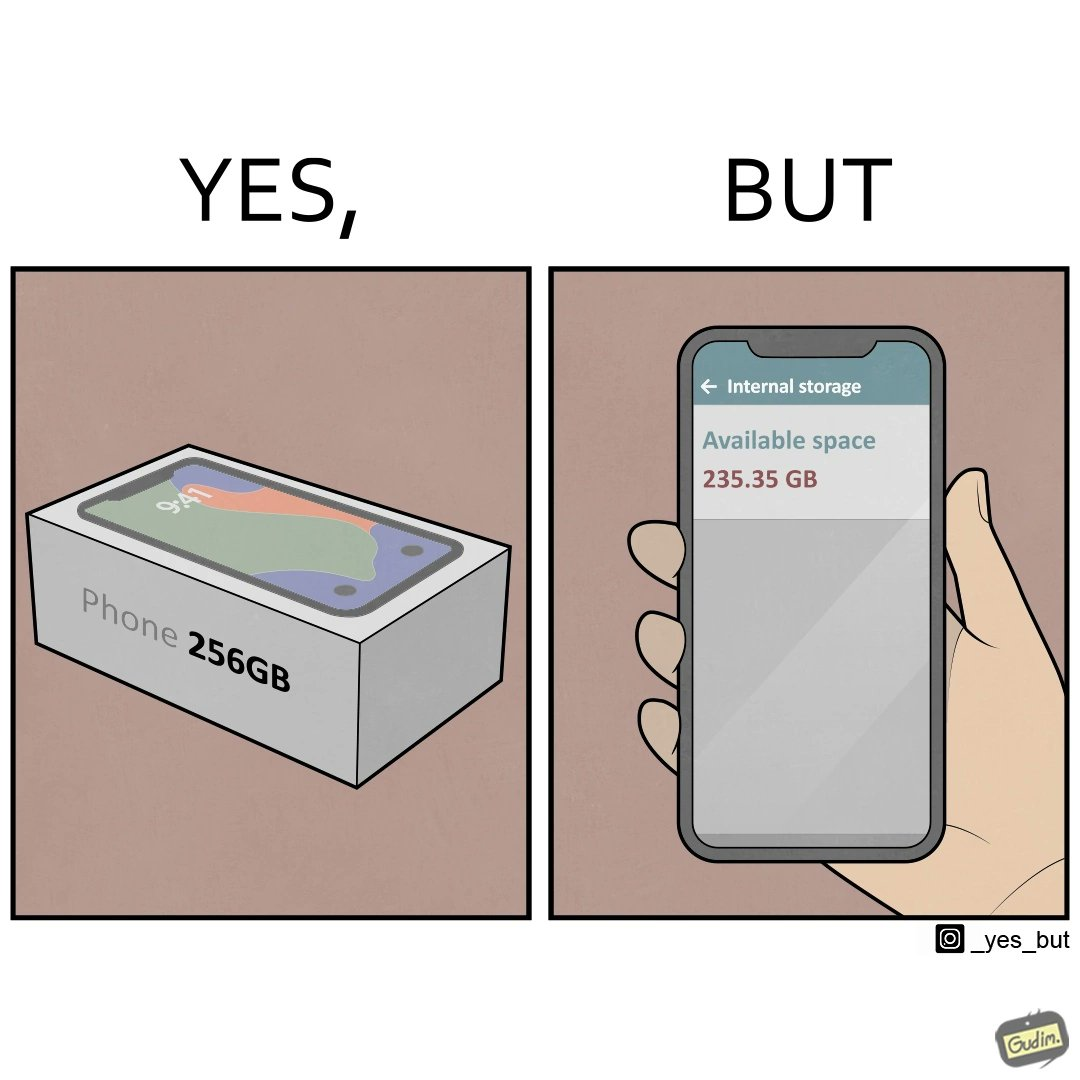Would you classify this image as satirical? Yes, this image is satirical. 